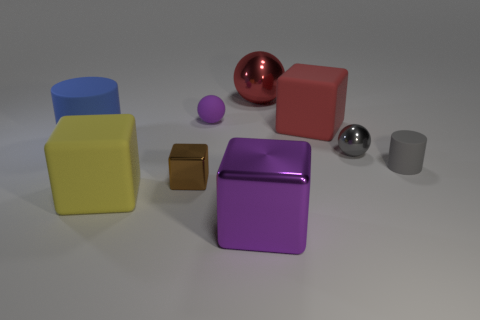Subtract 1 blocks. How many blocks are left? 3 Subtract all spheres. How many objects are left? 6 Add 7 red matte objects. How many red matte objects are left? 8 Add 5 tiny cyan spheres. How many tiny cyan spheres exist? 5 Subtract 1 brown blocks. How many objects are left? 8 Subtract all large shiny cubes. Subtract all large purple objects. How many objects are left? 7 